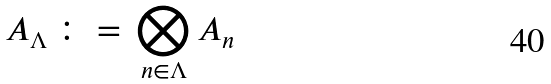Convert formula to latex. <formula><loc_0><loc_0><loc_500><loc_500>A _ { \Lambda } \, \colon = \, \bigotimes _ { n \in \Lambda } A _ { n }</formula> 